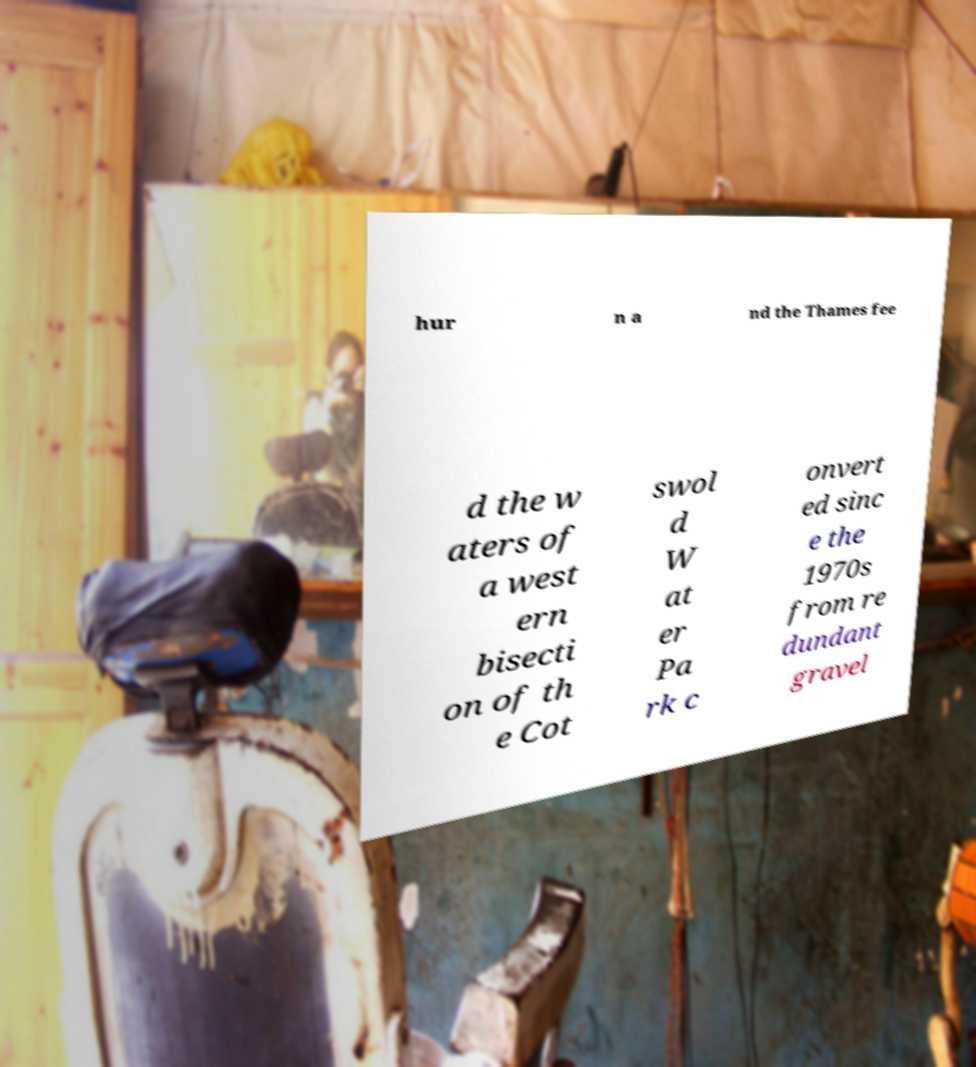There's text embedded in this image that I need extracted. Can you transcribe it verbatim? hur n a nd the Thames fee d the w aters of a west ern bisecti on of th e Cot swol d W at er Pa rk c onvert ed sinc e the 1970s from re dundant gravel 